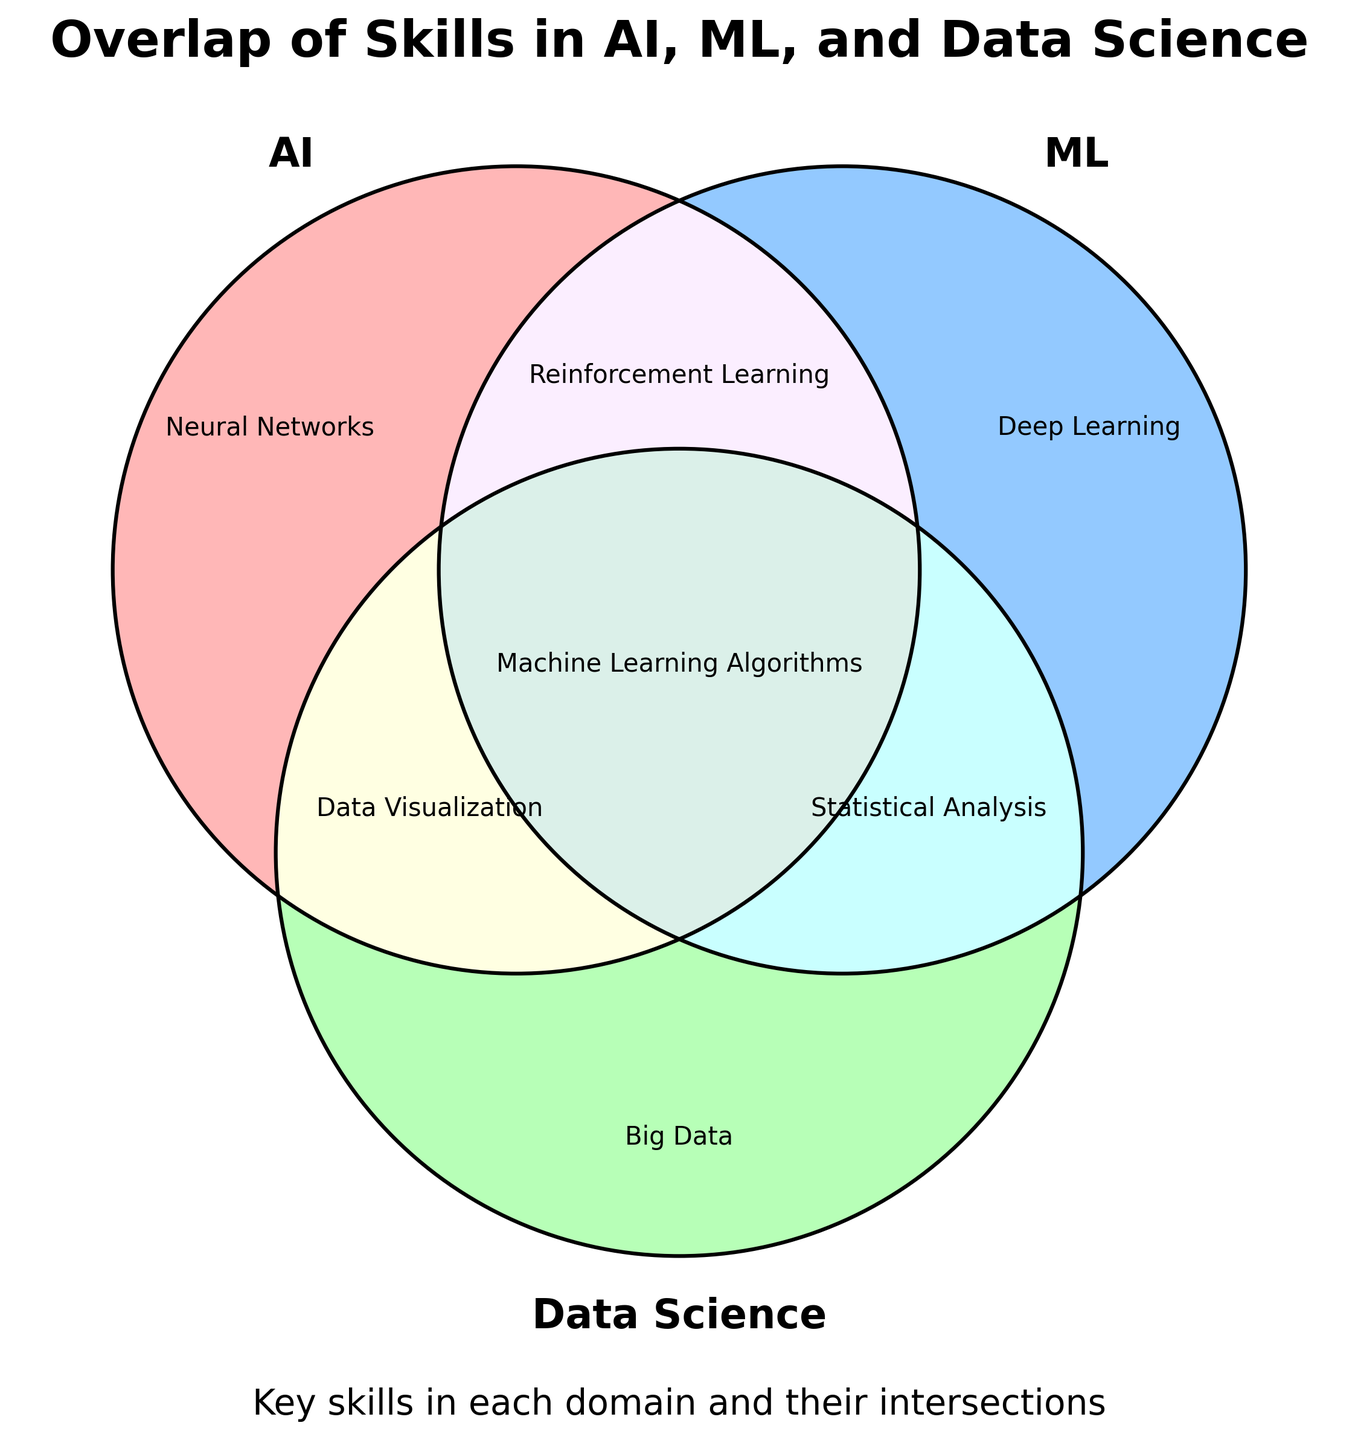What is the title of the Venn diagram? The title of the Venn diagram is typically located at the top of the figure. In this case, the title of the diagram is "Overlap of Skills in AI, ML, and Data Science."
Answer: Overlap of Skills in AI, ML, and Data Science Which section of the Venn diagram represents skills unique to AI? The section of the Venn diagram representing skills unique to AI is indicated by the region with the label 'AI' only, which is shown on the left circle of the diagram.
Answer: AI What skills are unique to Data Science? The skills unique to Data Science are listed in the section designated for Data Science alone. According to the provided data, these skills include Big Data, Data Mining, Database Management, and ETL Processes.
Answer: Big Data, Data Mining, Database Management, ETL Processes Which skill is indicated at the intersection of AI and Machine Learning? The intersection of the AI and Machine Learning circles is where skills relevant to both domains are listed. According to the provided data, the skill shown in this intersecting region is Reinforcement Learning.
Answer: Reinforcement Learning What skills are shared among AI, ML, and Data Science? The skills shared among AI, ML, and Data Science are located in the central region where all three circles intersect. These include Machine Learning Algorithms, Python Programming, and Scikit-learn.
Answer: Machine Learning Algorithms, Python Programming, Scikit-learn How many skills are unique to Machine Learning (ML)? Count the skills listed in the section marked for Machine Learning alone, which includes Deep Learning, Gradient Boosting, Random Forests, and Support Vector Machines.
Answer: 4 Which domain(s) do the skills "Dimensionality Reduction" and "Data Cleaning" intersect? Dimensionality Reduction is located at the intersection of ML and Data Science (ML & DS), while Data Cleaning is located at the intersection of AI and Data Science (AI & DS).
Answer: ML & DS, AI & DS What are the skills exclusively shared between AI and Data Science, but not ML? The skills exclusively shared between AI and Data Science are listed in the overlapping region of AI and Data Science, excluding ML. According to the data, these include Data Visualization and Generative AI.
Answer: Data Visualization, Generative AI Are there more skills unique to AI or those shared between ML and Data Science? Evaluate the count of skills in both regions. AI has four unique skills: Neural Networks, Natural Language Processing, Expert Systems, and Cognitive Computing. The intersection of ML and Data Science lists Statistical Analysis, Regression Analysis, Clustering, and Dimensionality Reduction; also four skills.
Answer: Equal number What skill appears at the intersection of AI, ML, and Data Science and is used for implementing machine learning models? The skill appearing at this intersection is TensorFlow, which is used for implementing machine learning models.
Answer: TensorFlow 